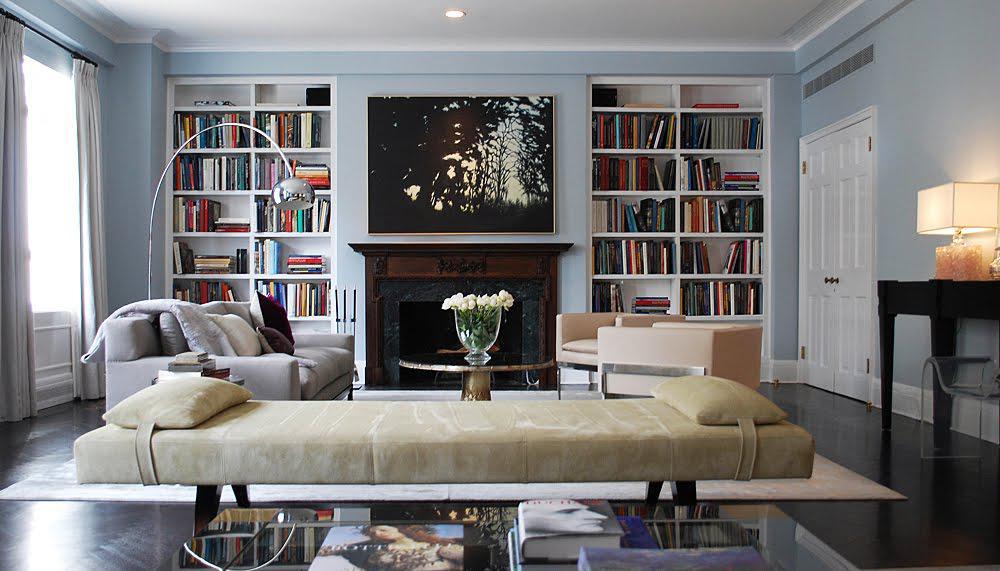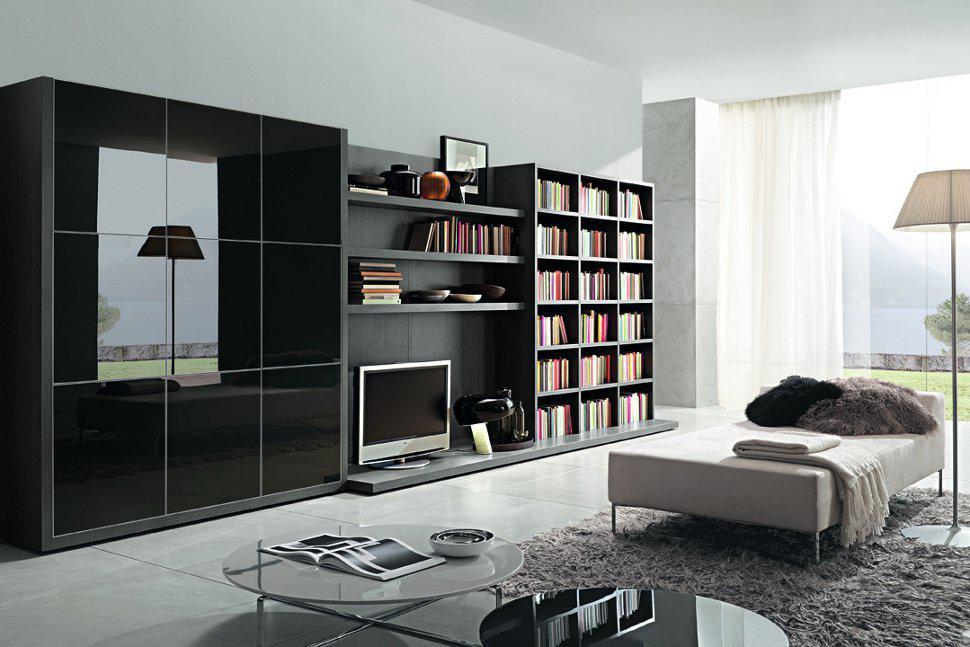The first image is the image on the left, the second image is the image on the right. Given the left and right images, does the statement "One image shows a room with black bookshelves along one side of a storage unit, with a TV in the center and glass-fronted squares opposite the bookshelves." hold true? Answer yes or no. Yes. The first image is the image on the left, the second image is the image on the right. Given the left and right images, does the statement "The lamp in the image on the left is sitting on a table." hold true? Answer yes or no. Yes. 